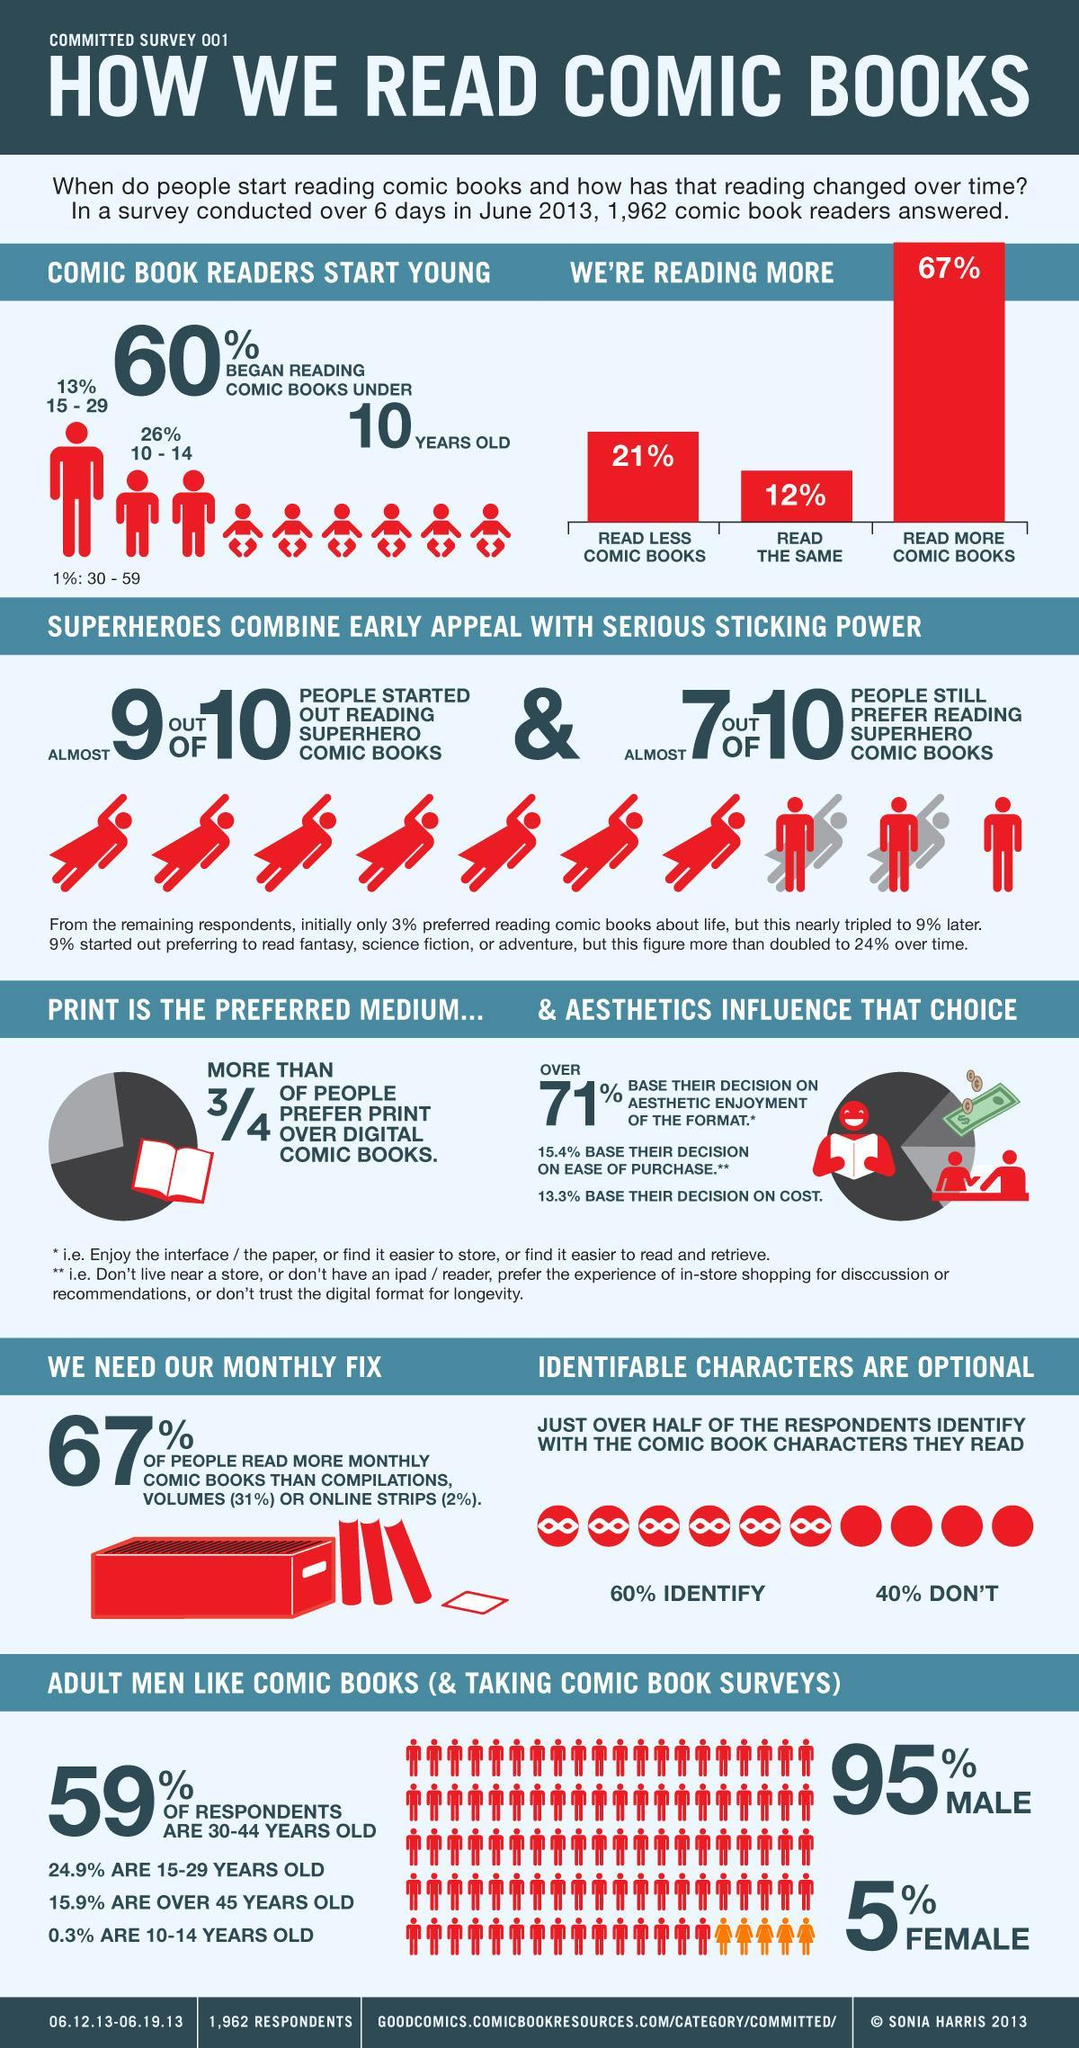What percent of men like reading comic books according to the survey conducted in June 2013?
Answer the question with a short phrase. 95% What percent of comic book readers started reading at the age of 15-29 years according to the survey conducted in June 2013? 13% What percentage of comic book readers read less comic books as per the survey conducted in June 2013? 21% What percent of comic book readers started reading at the age of 10-14 years according to the survey conducted in June 2013? 26% What percent of women like reading comic books according to the survey conducted in June 2013? 5% What percentage of comic book readers read more comic books as per the survey conducted in June 2013? 67% What percent of the respondents don't identify with the comic book characters they read according to the survey conducted in June 2013? 40% 